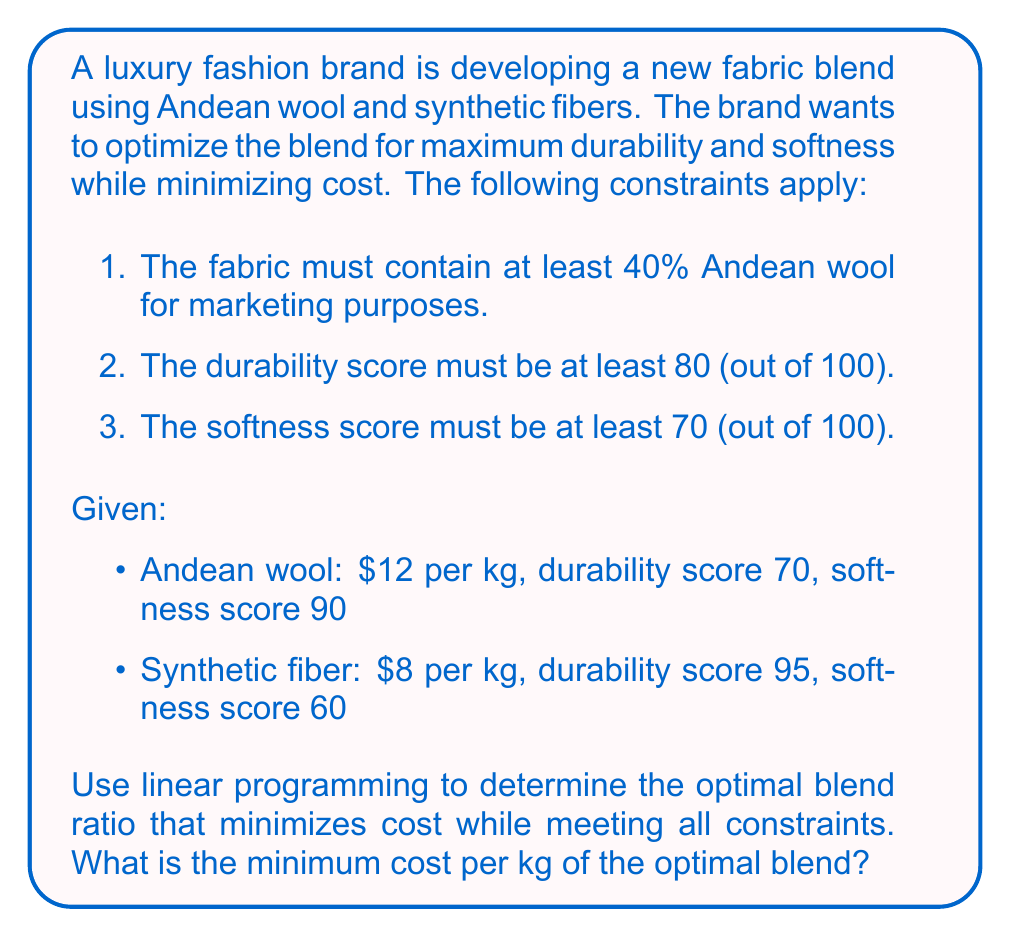Can you answer this question? Let's approach this problem step-by-step using linear programming:

1. Define variables:
   Let $x$ be the proportion of Andean wool
   Let $y$ be the proportion of synthetic fiber

2. Objective function (minimize cost):
   $\text{Cost} = 12x + 8y$

3. Constraints:
   a) Sum of proportions: $x + y = 1$
   b) Minimum wool content: $x \geq 0.4$
   c) Durability score: $70x + 95y \geq 80$
   d) Softness score: $90x + 60y \geq 70$

4. Set up the linear programming problem:

   Minimize: $12x + 8y$
   Subject to:
   $x + y = 1$
   $x \geq 0.4$
   $70x + 95y \geq 80$
   $90x + 60y \geq 70$
   $x, y \geq 0$

5. Solve the system:
   We can use the corner point method to find the optimal solution.

   From $x + y = 1$ and $x \geq 0.4$, we get:
   $0.4 \leq x \leq 1$ and $0 \leq y \leq 0.6$

   Check the corner points:
   (0.4, 0.6): Satisfies all constraints
   (1, 0): Does not satisfy durability constraint

   The optimal solution will be at (0.4, 0.6) or at the intersection of two constraint lines.

   Solving $70x + 95y = 80$ and $90x + 60y = 70$ simultaneously:
   $x \approx 0.5714$, $y \approx 0.4286$

   This point satisfies all constraints and is a feasible solution.

6. Evaluate the objective function at feasible points:
   At (0.4, 0.6): $12(0.4) + 8(0.6) = 9.6$
   At (0.5714, 0.4286): $12(0.5714) + 8(0.4286) = 10.2856$

Therefore, the optimal blend ratio is 40% Andean wool and 60% synthetic fiber.
Answer: The minimum cost per kg of the optimal blend is $9.60. 